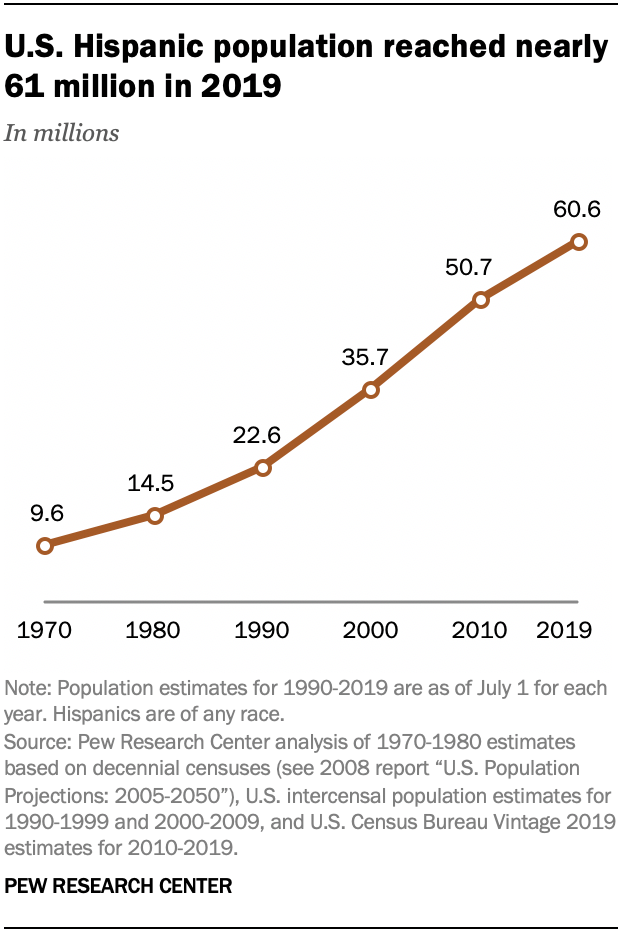Draw attention to some important aspects in this diagram. The value of the U.S. Hispanic population is expected to fall below 35 million in the next X years. The U.S. Hispanic population in 2010 was estimated to be approximately 50.7 million. 